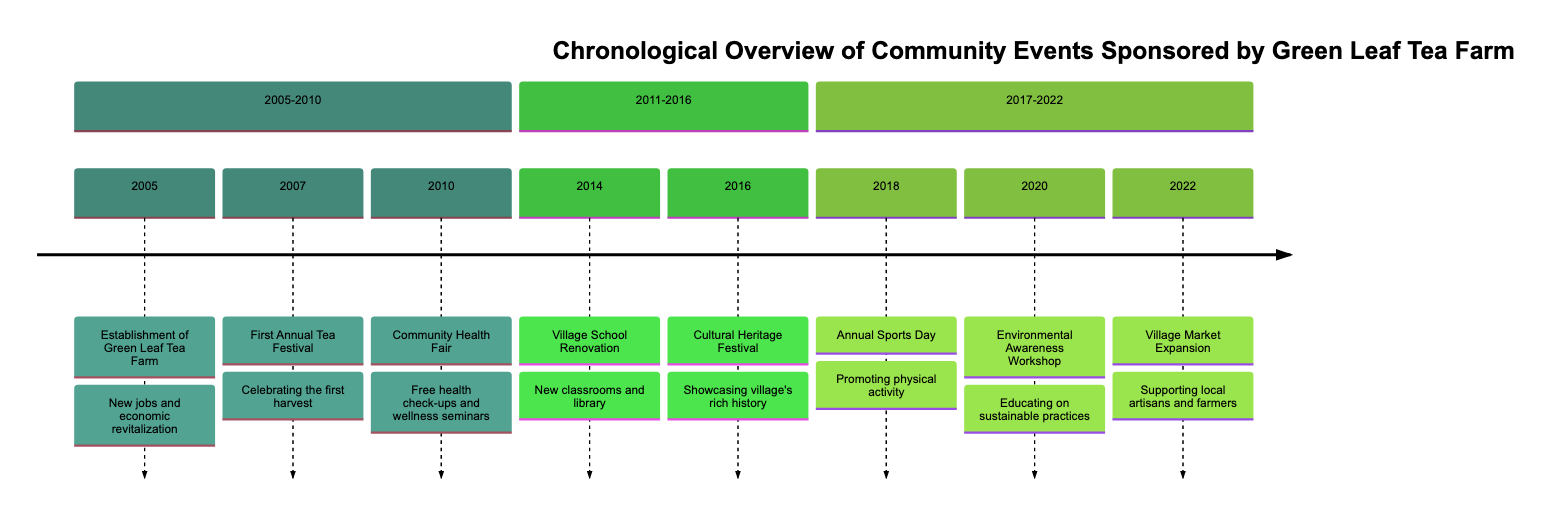What year was the Green Leaf Tea Farm established? The diagram indicates that the establishment event is listed under the year 2005.
Answer: 2005 What event occurred in 2014? Referring to the timeline, the 2014 event is the Village School Renovation.
Answer: Village School Renovation How many events took place between 2005 and 2010? Counting the events in that timeframe, there are three listed: the establishment of the tea farm, the first annual tea festival, and the community health fair.
Answer: 3 Which festival celebrated the first harvest? The diagram specifies that the first annual tea festival, which occurred in 2007, was the event celebrating the first harvest.
Answer: First Annual Tea Festival What type of event was held in 2020? According to the timeline, the event in 2020 was an Environmental Awareness Workshop.
Answer: Environmental Awareness Workshop What was sponsored by the tea farm in 2016? The diagram shows that the Cultural Heritage Festival was sponsored by the tea farm in 2016.
Answer: Cultural Heritage Festival Which two events are related to community health? The community health fair in 2010 and the environmental awareness workshop in 2020 are both related to health and wellness initiatives supported by the tea farm.
Answer: Community Health Fair and Environmental Awareness Workshop What was the impact of the tea farm on the village market in 2022? The timeline states that the tea farm supported the expansion of the village market, allowing local artisans and farmers to sell products more effectively.
Answer: Village Market Expansion How many sections are in the timeline? The timeline is divided into three sections: 2005-2010, 2011-2016, and 2017-2022, thus there are three sections total.
Answer: 3 